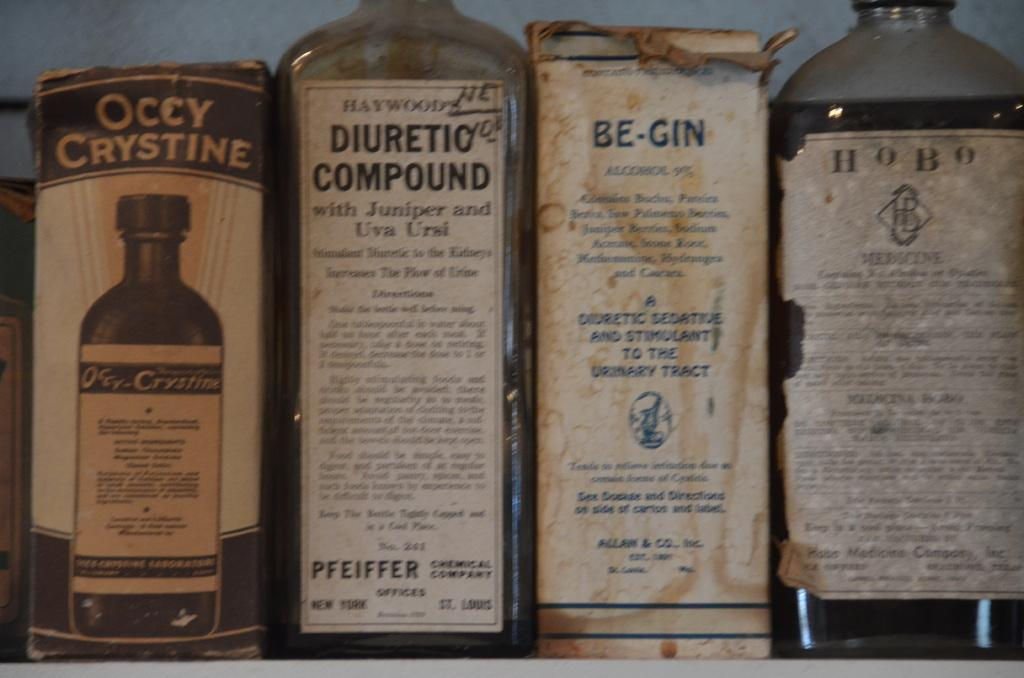<image>
Write a terse but informative summary of the picture. Some really old elixers including a diuretic compund. 